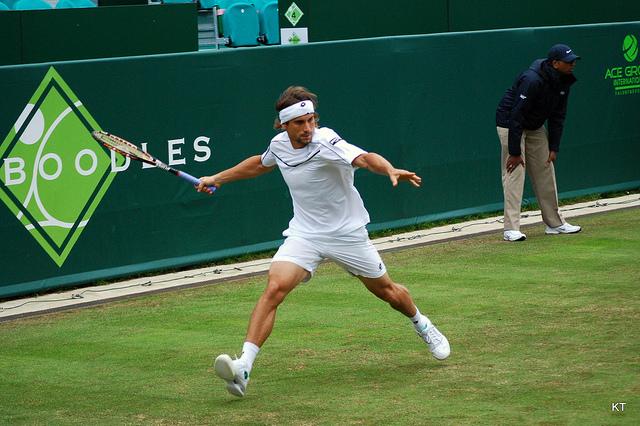How many seats can you see?
Give a very brief answer. 2. What is the man holding?
Quick response, please. Tennis racket. What color is the man's pants in the background?
Short answer required. Tan. 